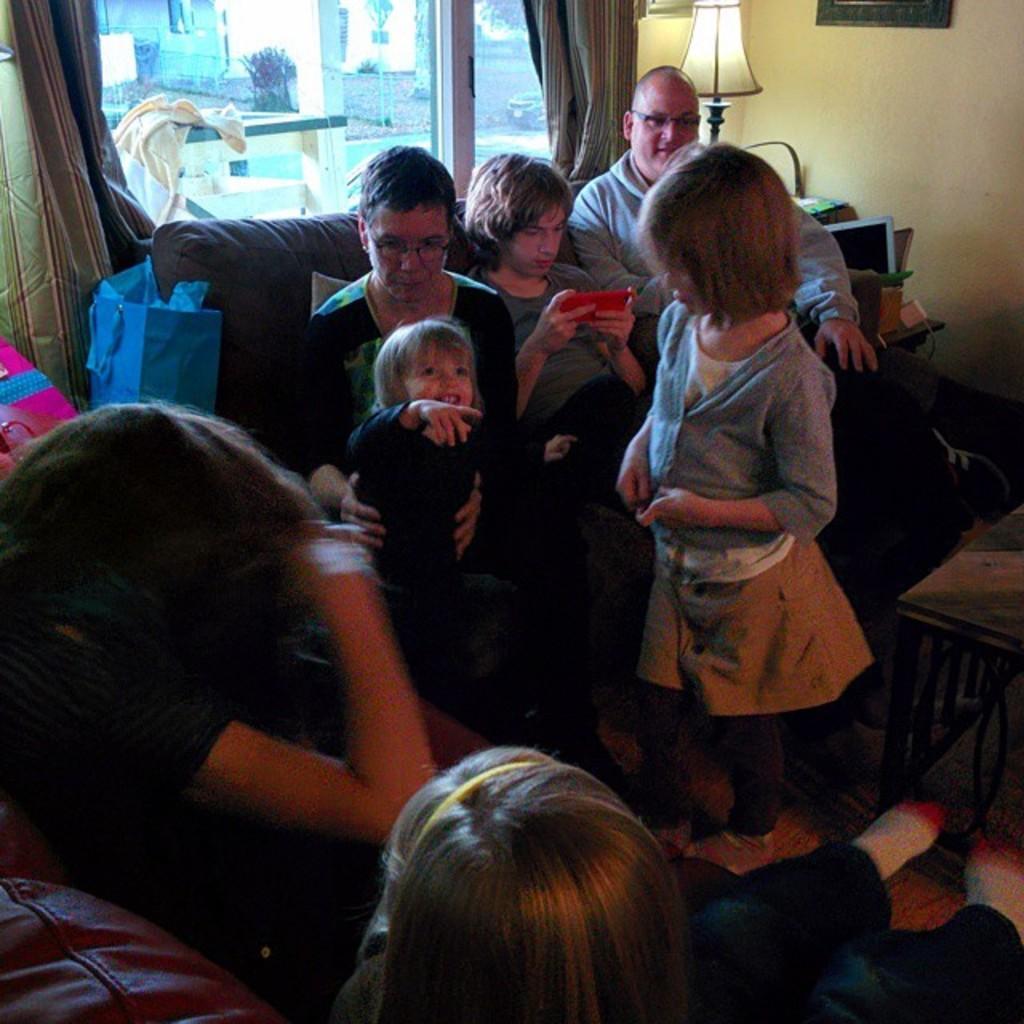How would you summarize this image in a sentence or two? We can see a group of persons in the middle of this image and there is a wall in the background. There is a glass window at the top of this image. There is a lamp present on the right side to this window. 